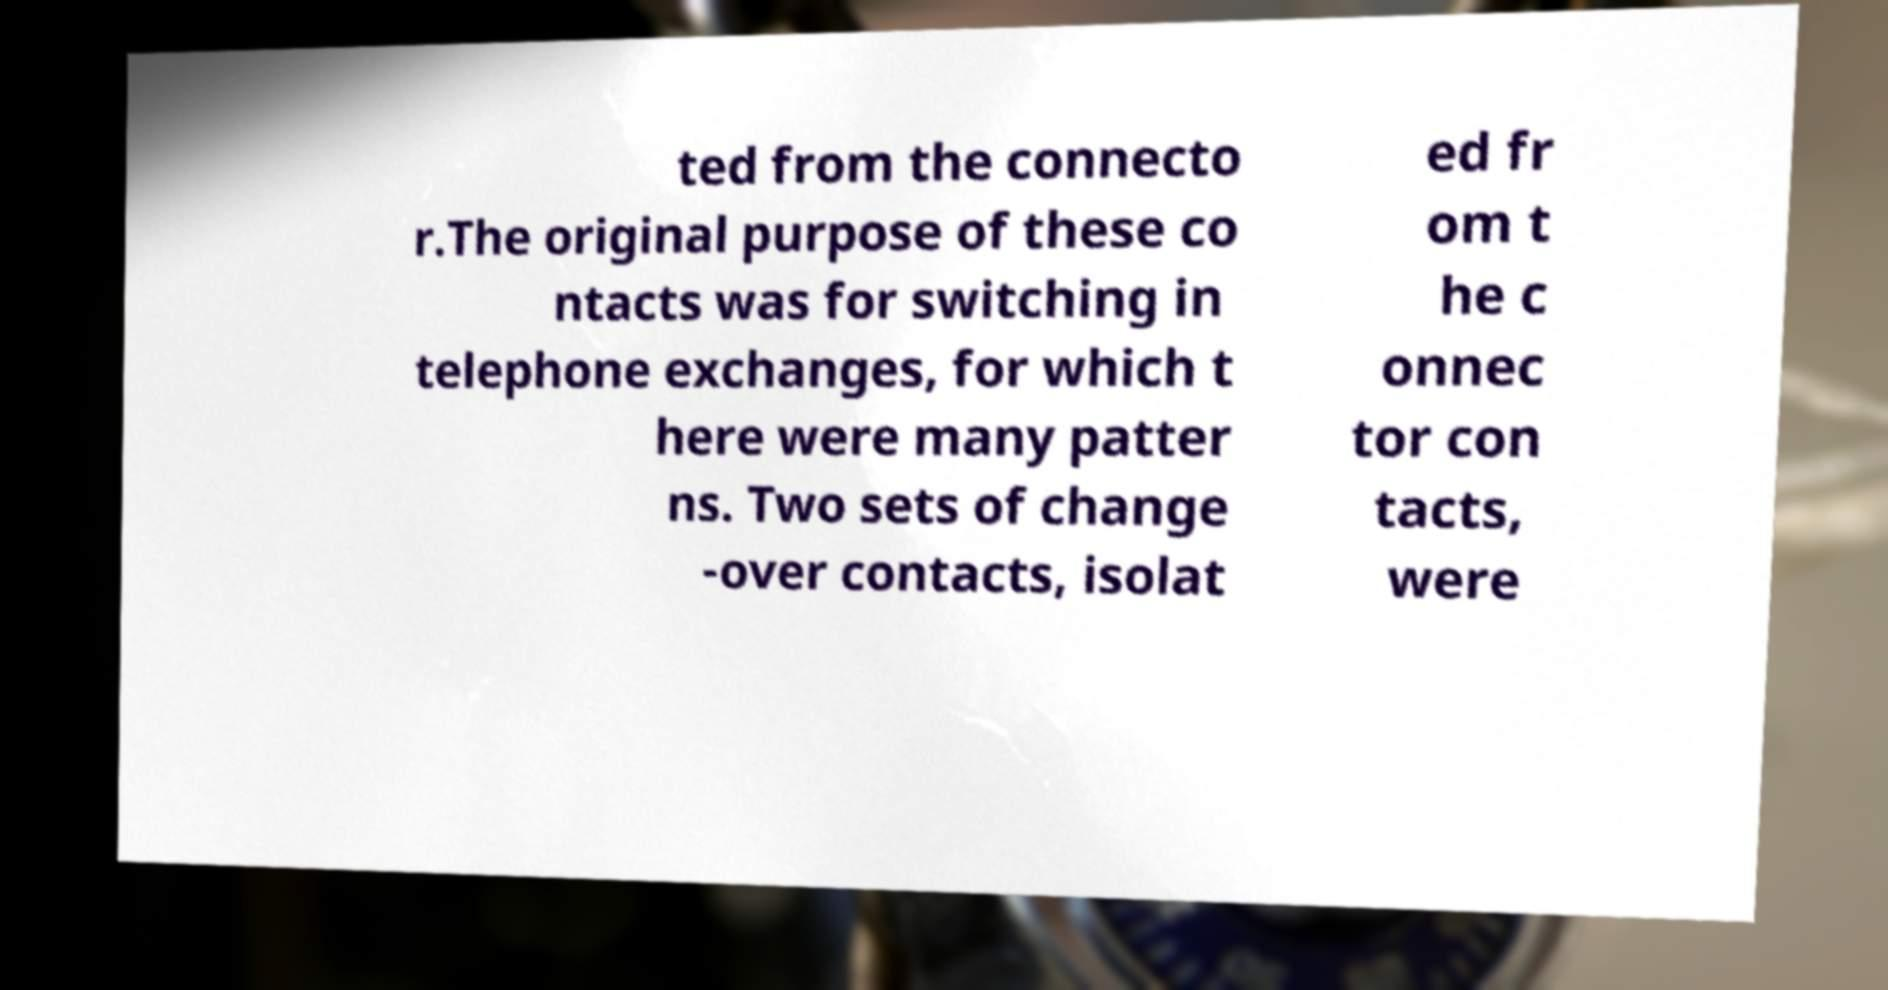Could you assist in decoding the text presented in this image and type it out clearly? ted from the connecto r.The original purpose of these co ntacts was for switching in telephone exchanges, for which t here were many patter ns. Two sets of change -over contacts, isolat ed fr om t he c onnec tor con tacts, were 